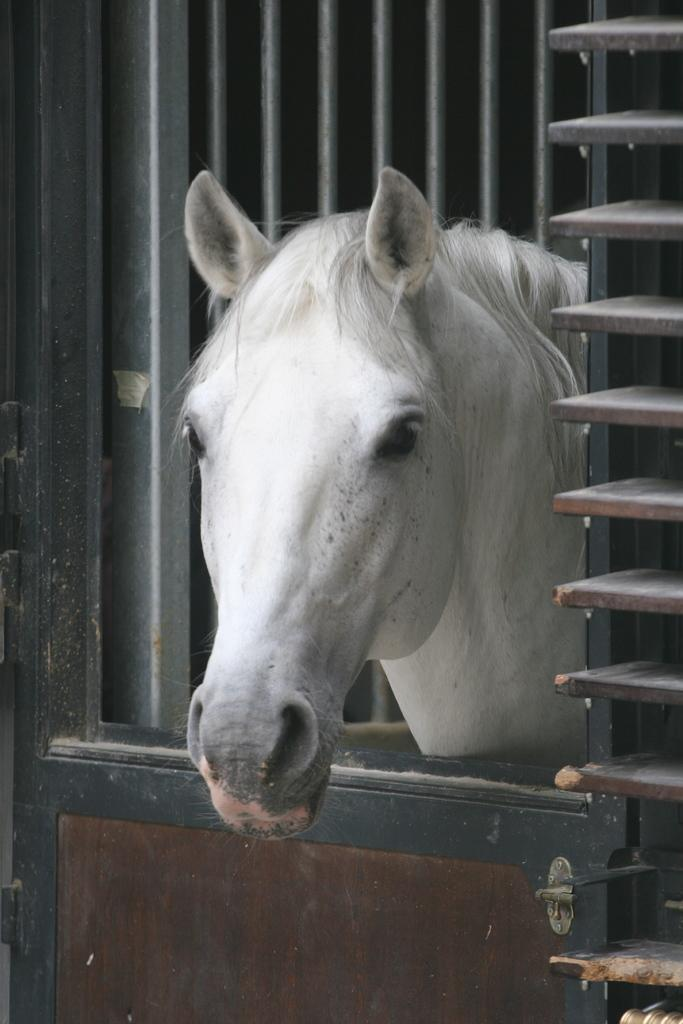What can be seen in the image? There is a window in the image, and a horse head is visible in the window. Can you describe the window's appearance? The facts provided do not give specific details about the window's appearance, but it is a part of the image. Are there any pets visible in the image? No, there are no pets visible in the image; only a horse head is visible in the window. Is the horse head painted on a canvas? No, the facts provided do not mention a canvas, and the horse head is visible in the window, not on a canvas. 